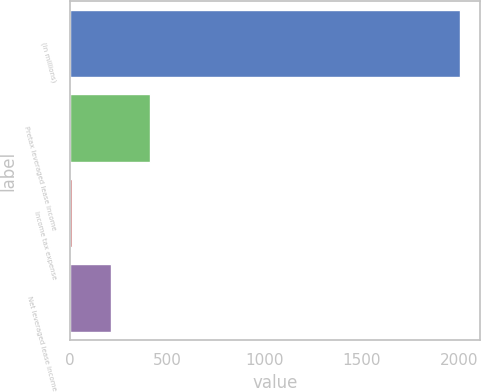<chart> <loc_0><loc_0><loc_500><loc_500><bar_chart><fcel>(in millions)<fcel>Pretax leveraged lease income<fcel>Income tax expense<fcel>Net leveraged lease income<nl><fcel>2006<fcel>408.4<fcel>9<fcel>208.7<nl></chart> 